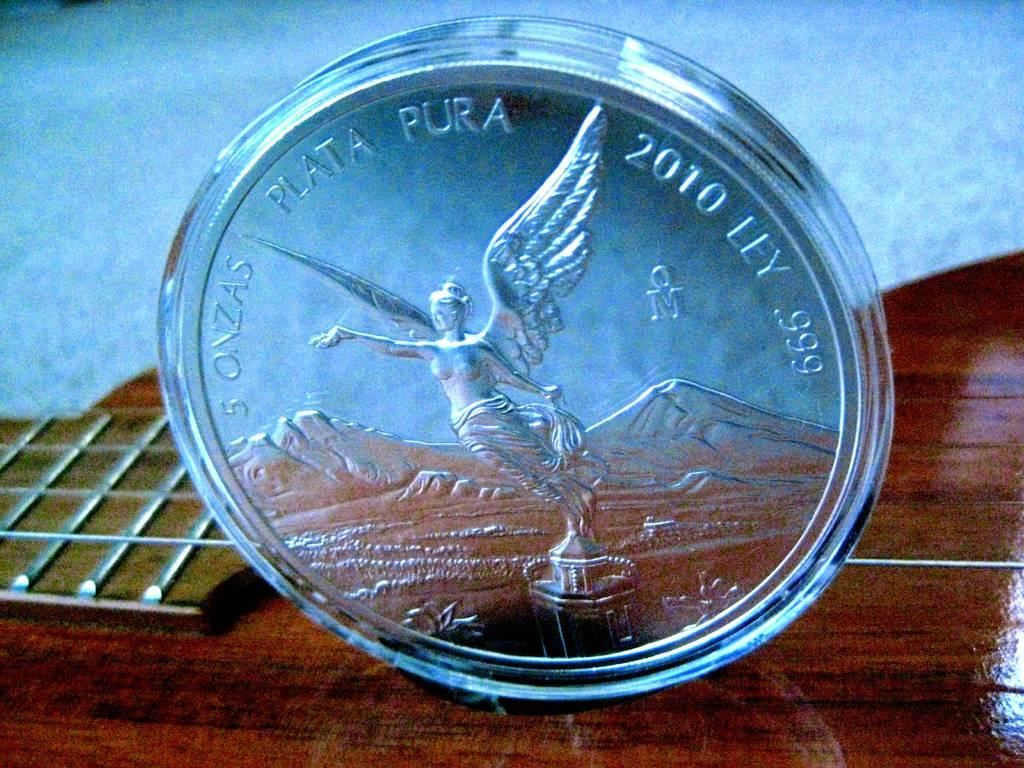<image>
Describe the image concisely. The beautiful coin in a protective case was made in 2010. 